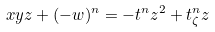<formula> <loc_0><loc_0><loc_500><loc_500>x y z + ( - w ) ^ { n } = - t ^ { n } z ^ { 2 } + t _ { \zeta } ^ { n } z</formula> 